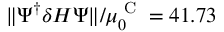<formula> <loc_0><loc_0><loc_500><loc_500>\| \Psi ^ { \dagger } \delta H \Psi \| / \mu _ { 0 } ^ { C } = 4 1 . 7 3</formula> 